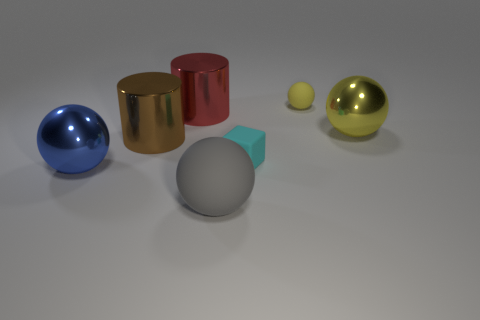Does the tiny matte sphere have the same color as the big shiny sphere in front of the large yellow shiny sphere?
Your response must be concise. No. What is the shape of the big brown shiny thing?
Your answer should be compact. Cylinder. What size is the metal sphere on the left side of the big thing right of the big sphere that is in front of the blue sphere?
Your answer should be compact. Large. How many other things are the same shape as the cyan rubber thing?
Offer a very short reply. 0. Do the rubber thing that is behind the red shiny cylinder and the large thing in front of the blue ball have the same shape?
Give a very brief answer. Yes. What number of balls are brown metallic things or tiny yellow matte objects?
Ensure brevity in your answer.  1. There is a yellow sphere left of the yellow ball that is in front of the matte object that is right of the matte cube; what is it made of?
Ensure brevity in your answer.  Rubber. How many other things are there of the same size as the yellow metallic object?
Offer a terse response. 4. The shiny object that is the same color as the tiny rubber sphere is what size?
Offer a terse response. Large. Are there more large metal balls right of the large blue object than small purple blocks?
Your answer should be compact. Yes. 